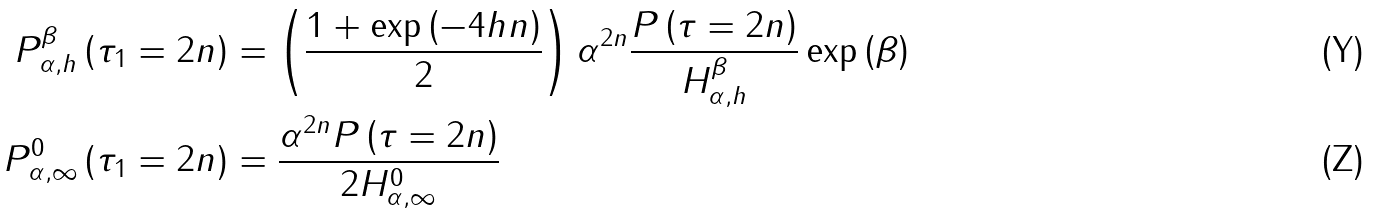Convert formula to latex. <formula><loc_0><loc_0><loc_500><loc_500>P _ { \alpha , h } ^ { \beta } \left ( \tau _ { 1 } = 2 n \right ) & = \left ( \frac { 1 + \exp \left ( - 4 h n \right ) } { 2 } \right ) \alpha ^ { 2 n } \frac { P \left ( \tau = 2 n \right ) } { H _ { \alpha , h } ^ { \beta } } \exp \left ( \beta \right ) \\ P _ { \alpha , \infty } ^ { 0 } \left ( \tau _ { 1 } = 2 n \right ) & = \frac { \alpha ^ { 2 n } P \left ( \tau = 2 n \right ) } { 2 H _ { \alpha , \infty } ^ { 0 } }</formula> 